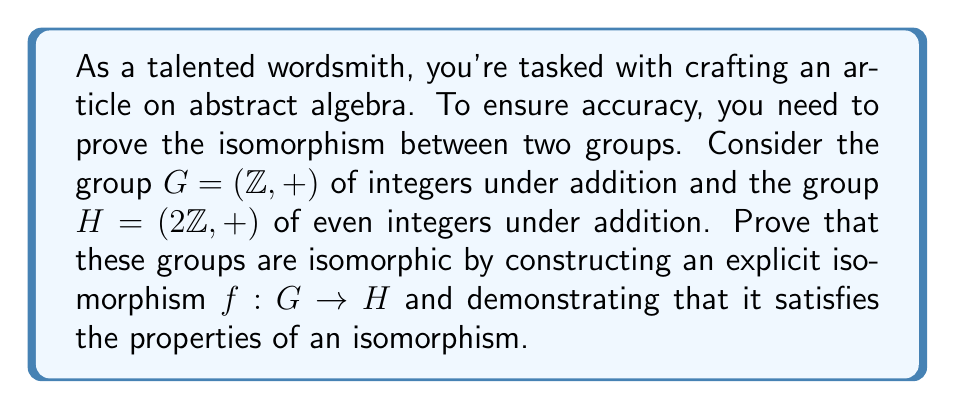Teach me how to tackle this problem. To prove that the groups $G = (\mathbb{Z}, +)$ and $H = (2\mathbb{Z}, +)$ are isomorphic, we need to construct a bijective homomorphism $f: G \to H$. Let's proceed step by step:

1. Define the function $f: G \to H$ as $f(n) = 2n$ for all $n \in \mathbb{Z}$.

2. Prove that $f$ is a homomorphism:
   For any $a, b \in G$, we need to show that $f(a + b) = f(a) + f(b)$
   $$f(a + b) = 2(a + b) = 2a + 2b = f(a) + f(b)$$

3. Prove that $f$ is injective (one-to-one):
   Suppose $f(a) = f(b)$ for some $a, b \in G$
   Then $2a = 2b$
   Dividing both sides by 2, we get $a = b$
   Thus, $f$ is injective

4. Prove that $f$ is surjective (onto):
   For any $y \in H$, $y$ is an even integer, so $y = 2k$ for some $k \in \mathbb{Z}$
   Then $f(k) = 2k = y$
   Thus, every element in $H$ has a preimage in $G$ under $f$

5. Since $f$ is both injective and surjective, it is bijective

6. We have shown that $f$ is a bijective homomorphism, therefore it is an isomorphism between $G$ and $H$
Answer: The groups $G = (\mathbb{Z}, +)$ and $H = (2\mathbb{Z}, +)$ are isomorphic. An explicit isomorphism is given by the function $f: G \to H$ defined as $f(n) = 2n$ for all $n \in \mathbb{Z}$. 